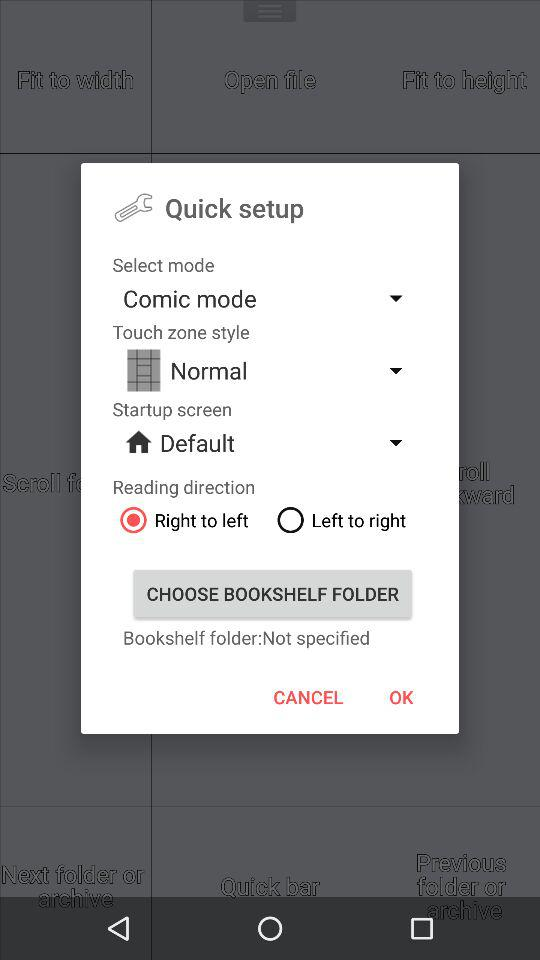How many options are there for the reading direction?
Answer the question using a single word or phrase. 2 